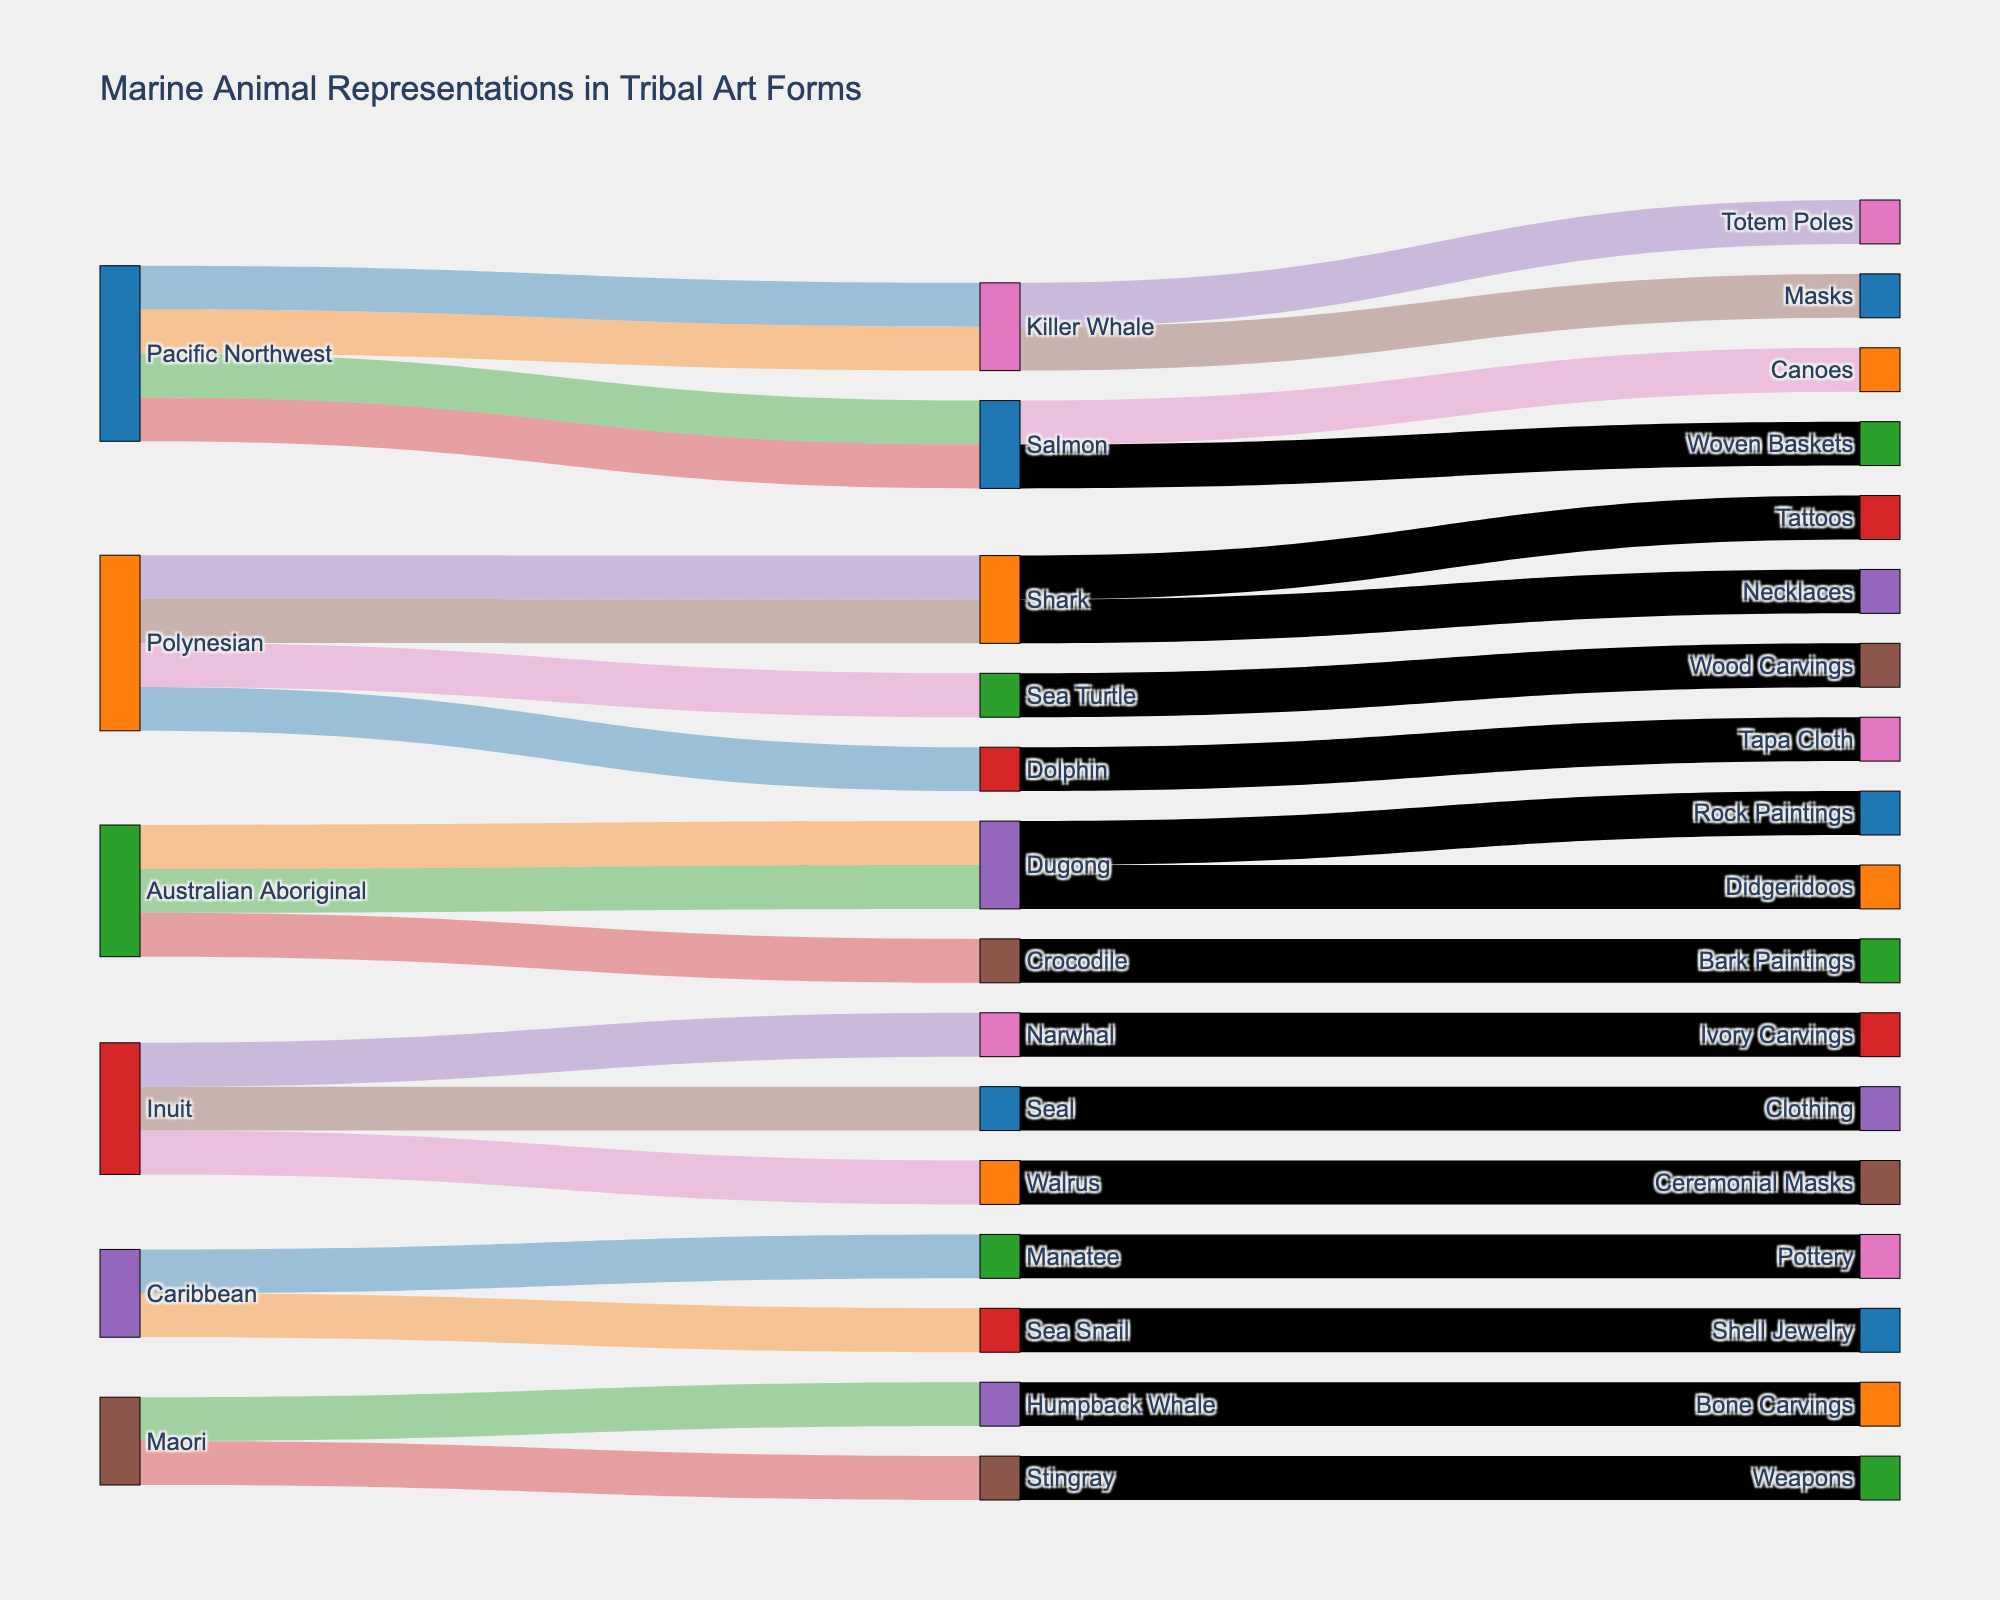Which source has the most diverse representation of marine animals in artifacts? Look at the source nodes and count the unique animals linked to each source. The Pacific Northwest has links to Killer Whale and Salmon, Polynesian has links to Shark, Sea Turtle, and Dolphin, Australian Aboriginal has links to Dugong and Crocodile, Inuit has links to Narwhal, Seal, and Walrus, and Caribbean has links to Manatee and Sea Snail, while Maori has links to Humpback Whale and Stingray. Thus, Polynesian and Inuit each represent three different marine animals, the most among the sources.
Answer: Polynesian and Inuit Which animal has representations in the highest number of different artifact types? Trace each animal node to see how many different artifacts they connect to. Killer Whale is linked to Totem Poles and Masks. Salmon is linked to Canoes and Woven Baskets. Dugong is linked to Rock Paintings and Didgeridoos. All other animals are linked to just one artifact type. Thus, Killer Whale, Salmon, and Dugong are each represented in two different artifact types.
Answer: Killer Whale, Salmon, and Dugong What artifacts are associated with the Killer Whale? Find the Killer Whale node and follow the links to its connected artifact nodes. The Killer Whale is linked to Totem Poles and Masks.
Answer: Totem Poles and Masks Which source contributes to the Tattoos artifact? Follow the links from the Tattoos node to its connected animal node, and then trace back to the source node connected to this animal. Tattoos is linked to Shark, which is in turn linked to Polynesian.
Answer: Polynesian How many different artifact types are associated with the Polynesian source? Identify all the artifact nodes connected via animals to the Polynesian source. Polynesian connects to Shark (Tattoos, Necklaces), Sea Turtle (Wood Carvings), and Dolphin (Tapa Cloth). This means Polynesian is linked to four different artifact types.
Answer: 4 Which animal is uniquely represented in just one artifact type and by only one source? Look for animals that have a single link from a source and a single link to an artifact. For instance, Sea Turtle is linked to Polynesian only and then to Wood Carvings only, indicating unique representation.
Answer: Sea Turtle From which source are the most types of cultural artifacts derived? Count the total number of unique artifact types each source is linked to through their various animals. Pacific Northwest, Polynesian, Australian Aboriginal, Inuit, Caribbean, and Maori sources have different numbers of linked artifacts. Polynesian source links to four artifact types through different animals, which is the highest.
Answer: Polynesian Which artifact type is linked to Narwhal? Find the Narwhal node and follow its link to the connected artifact node. Narwhal is linked to Ivory Carvings.
Answer: Ivory Carvings Which sources are associated with musical artifact types? Identify artifact types related to music such as Didgeridoos, and trace them back to their sources. Didgeridoos is linked to Dugong, which connects to the Australian Aboriginal source. No other musical artifacts are presented.
Answer: Australian Aboriginal 